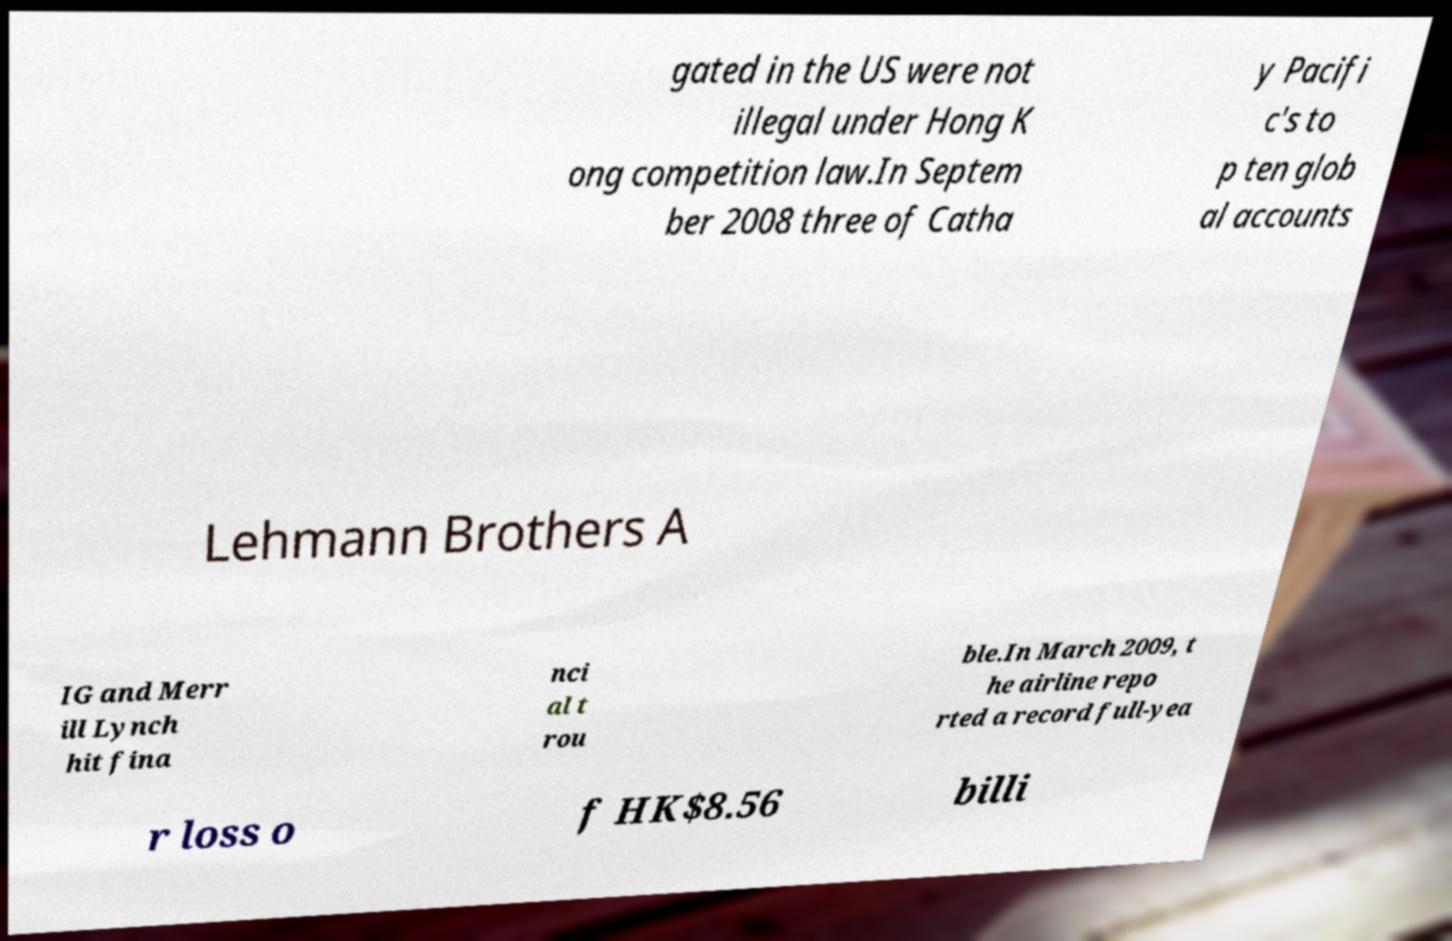Can you read and provide the text displayed in the image?This photo seems to have some interesting text. Can you extract and type it out for me? gated in the US were not illegal under Hong K ong competition law.In Septem ber 2008 three of Catha y Pacifi c's to p ten glob al accounts Lehmann Brothers A IG and Merr ill Lynch hit fina nci al t rou ble.In March 2009, t he airline repo rted a record full-yea r loss o f HK$8.56 billi 